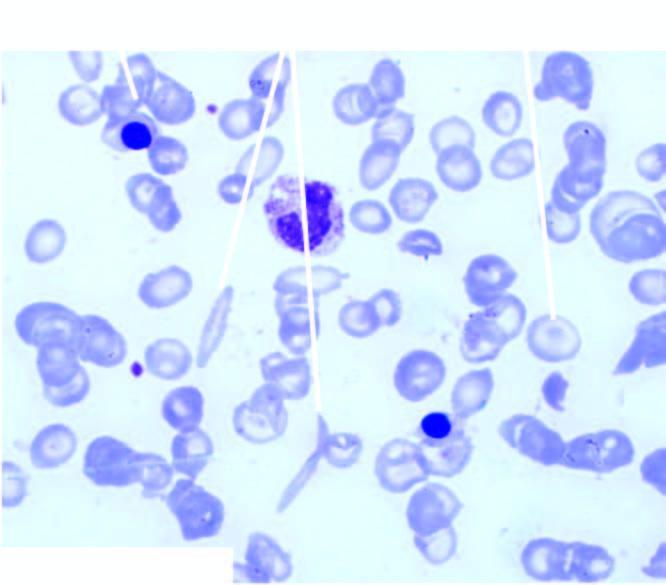does the peripheral zone show crescent shaped elongated red blood cells, a few target cells and a few erythroblasts?
Answer the question using a single word or phrase. No 